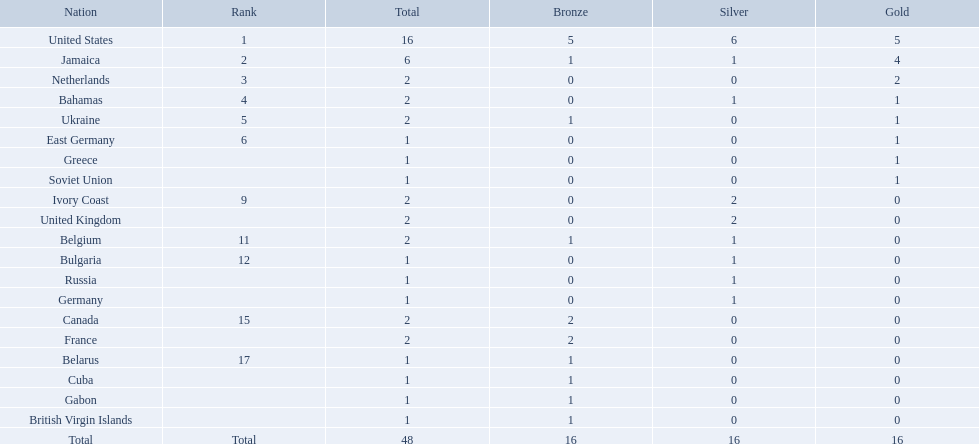What was the largest number of medals won by any country? 16. Which country won that many medals? United States. 